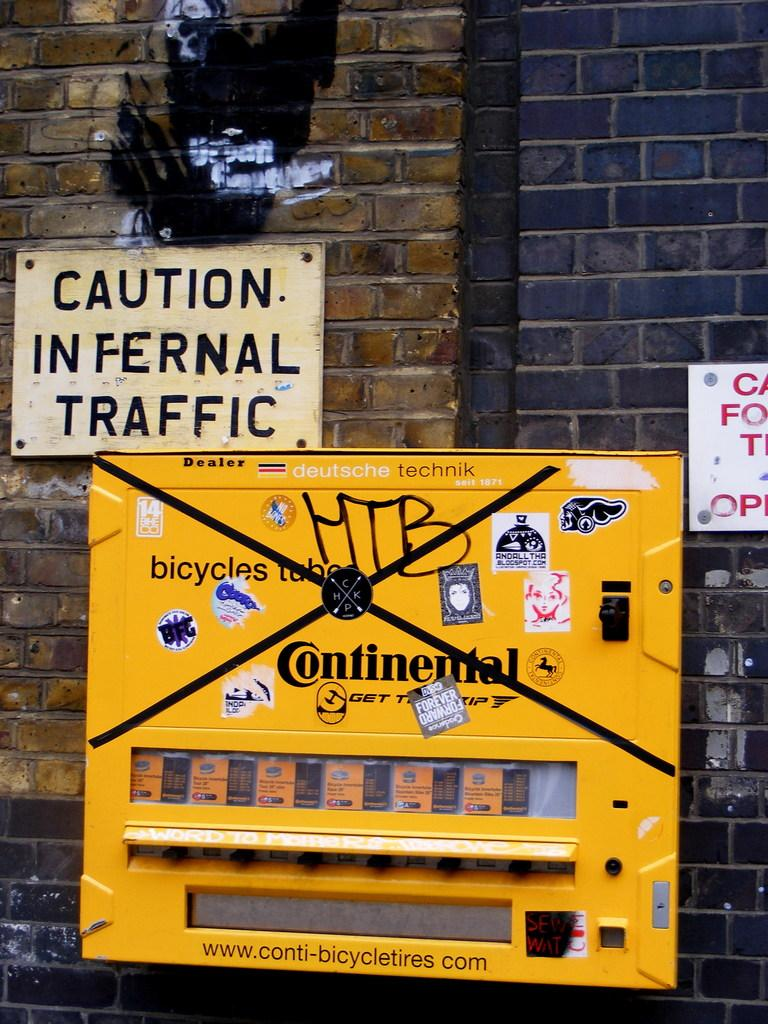What is the main object in the image? There is a machine in the image. What color is the machine? The machine is yellow in color. What can be seen on the wall in the background? There are boards attached to the wall in the background. What colors are used for the wall? The wall is in brown and black color. What type of war is being depicted in the image? There is no depiction of war in the image; it features a yellow machine and boards on a brown and black wall. Can you tell me how many coils are present in the image? There is no mention of coils in the image; it only features a machine, boards, and a wall. 